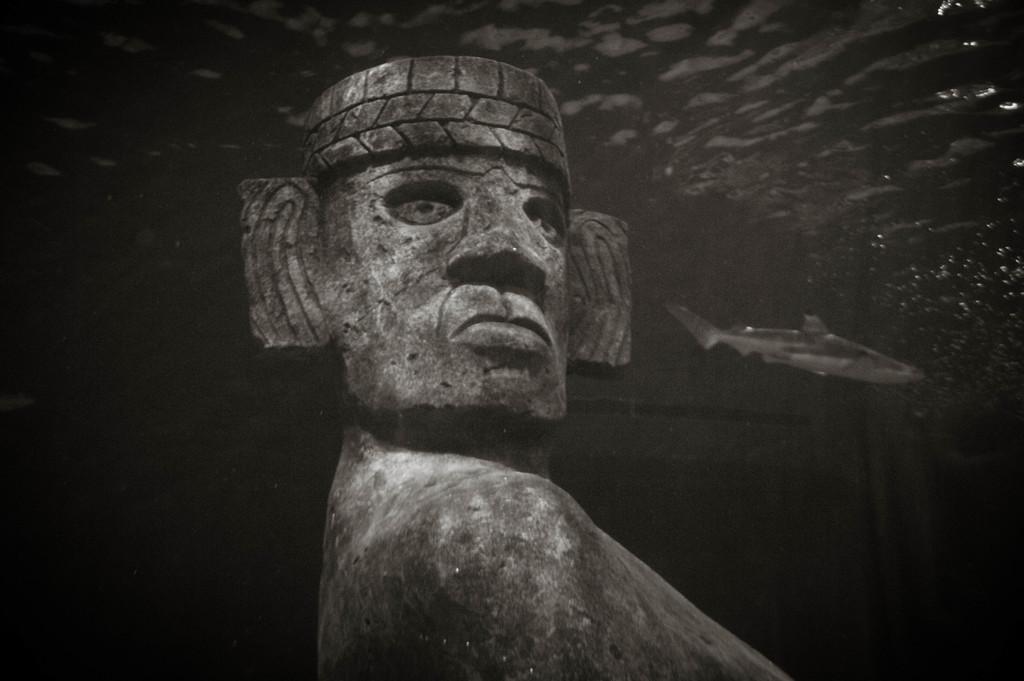Can you describe this image briefly? In this image I can see a sculpture of a person. On the right side there is a fish. I can see the black color background. 